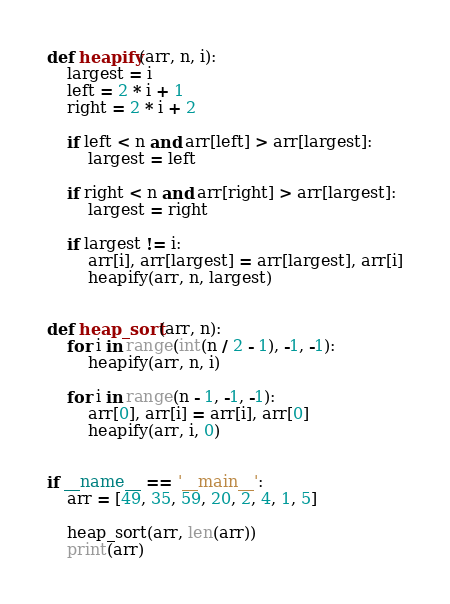<code> <loc_0><loc_0><loc_500><loc_500><_Python_>def heapify(arr, n, i):
    largest = i
    left = 2 * i + 1
    right = 2 * i + 2

    if left < n and arr[left] > arr[largest]:
        largest = left

    if right < n and arr[right] > arr[largest]:
        largest = right

    if largest != i:
        arr[i], arr[largest] = arr[largest], arr[i]
        heapify(arr, n, largest)


def heap_sort(arr, n):
    for i in range(int(n / 2 - 1), -1, -1):
        heapify(arr, n, i)

    for i in range(n - 1, -1, -1):
        arr[0], arr[i] = arr[i], arr[0]
        heapify(arr, i, 0)


if __name__ == '__main__':
    arr = [49, 35, 59, 20, 2, 4, 1, 5]

    heap_sort(arr, len(arr))
    print(arr)

</code> 